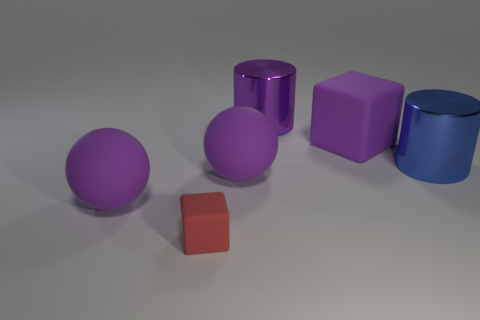How big is the rubber thing that is in front of the big blue thing and right of the red block?
Ensure brevity in your answer.  Large. There is a large rubber thing behind the big blue object; does it have the same shape as the shiny object that is left of the large blue metallic object?
Keep it short and to the point. No. What shape is the big metal thing that is the same color as the big matte cube?
Offer a very short reply. Cylinder. How many large brown cubes are made of the same material as the red cube?
Offer a very short reply. 0. There is a large object that is both in front of the large blue shiny thing and to the right of the red block; what shape is it?
Keep it short and to the point. Sphere. Is the material of the cube in front of the big purple cube the same as the purple cylinder?
Your response must be concise. No. Is there anything else that has the same material as the big blue cylinder?
Give a very brief answer. Yes. What is the color of the block that is the same size as the blue cylinder?
Give a very brief answer. Purple. Is there a tiny rubber block of the same color as the small object?
Give a very brief answer. No. What size is the blue cylinder that is the same material as the large purple cylinder?
Make the answer very short. Large. 